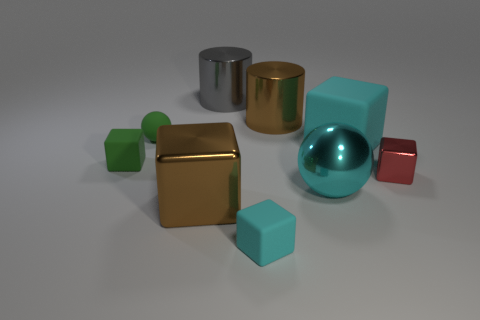Is there any other thing that has the same material as the green ball?
Your answer should be compact. Yes. There is a small rubber block to the left of the large gray metallic cylinder; does it have the same color as the cylinder to the right of the small cyan rubber object?
Provide a short and direct response. No. What number of objects are both left of the large brown metal block and behind the brown cylinder?
Your answer should be very brief. 0. How many other things are the same shape as the big cyan matte thing?
Provide a short and direct response. 4. Is the number of tiny cyan rubber things that are to the left of the big gray metallic cylinder greater than the number of small purple rubber balls?
Your answer should be very brief. No. There is a large block that is in front of the red object; what color is it?
Keep it short and to the point. Brown. What size is the rubber object that is the same color as the tiny ball?
Your response must be concise. Small. How many metallic things are big cyan spheres or cyan objects?
Give a very brief answer. 1. There is a brown shiny thing that is in front of the sphere in front of the small metal block; are there any shiny spheres in front of it?
Provide a short and direct response. No. There is a gray thing; how many large cyan metal spheres are to the right of it?
Your answer should be very brief. 1. 